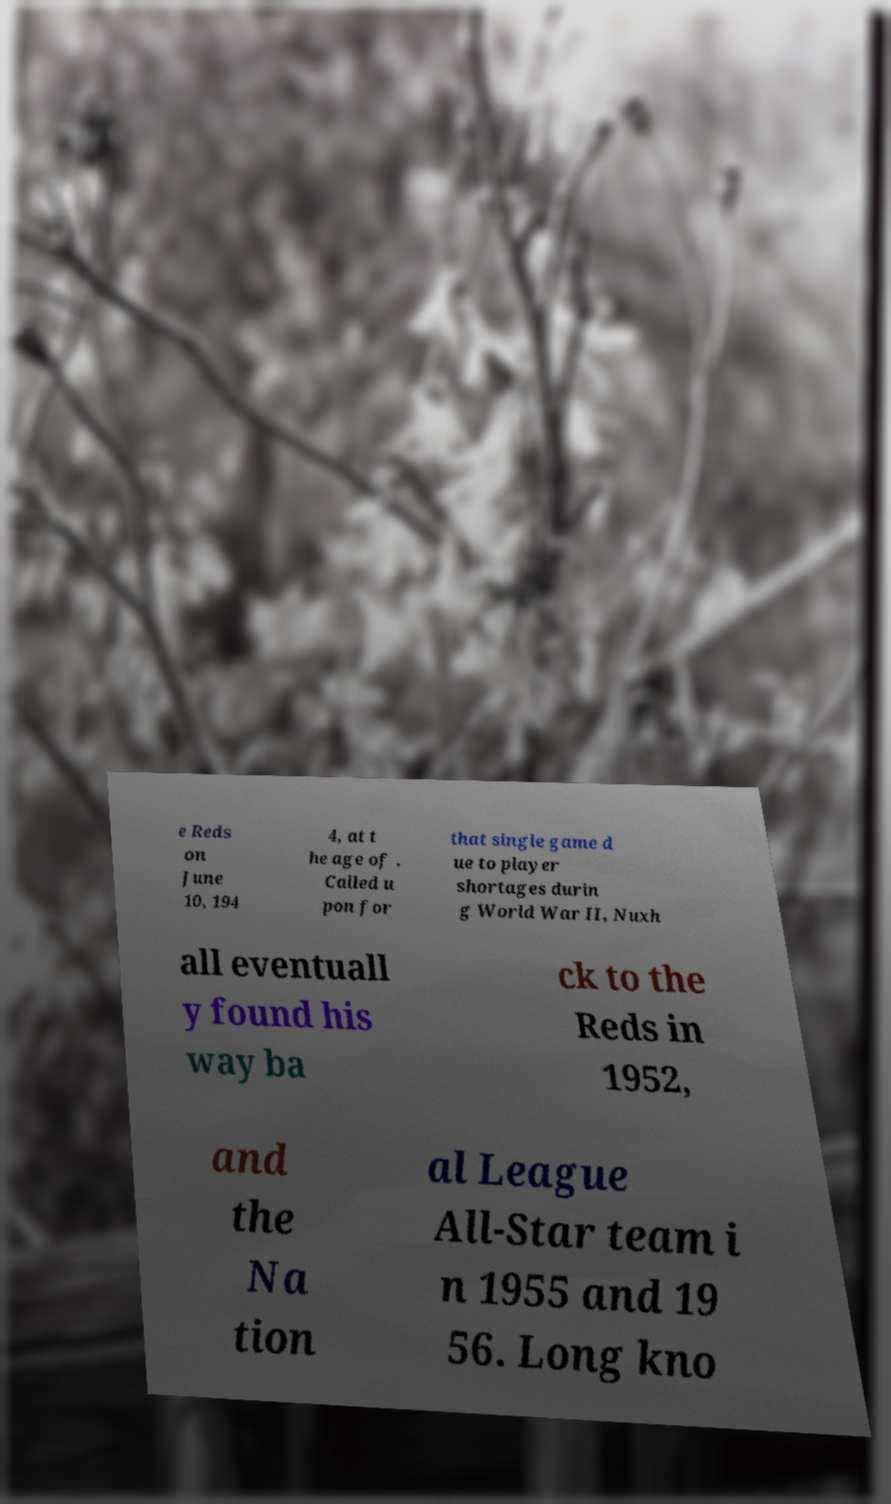Please read and relay the text visible in this image. What does it say? e Reds on June 10, 194 4, at t he age of . Called u pon for that single game d ue to player shortages durin g World War II, Nuxh all eventuall y found his way ba ck to the Reds in 1952, and the Na tion al League All-Star team i n 1955 and 19 56. Long kno 